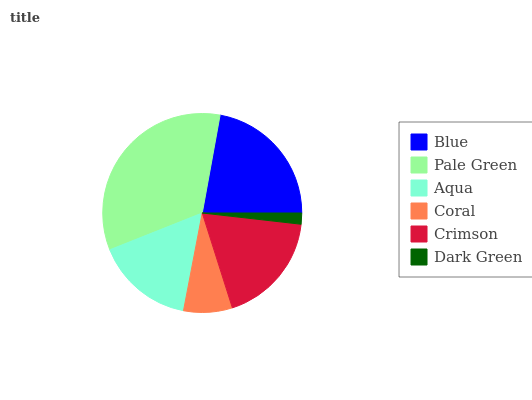Is Dark Green the minimum?
Answer yes or no. Yes. Is Pale Green the maximum?
Answer yes or no. Yes. Is Aqua the minimum?
Answer yes or no. No. Is Aqua the maximum?
Answer yes or no. No. Is Pale Green greater than Aqua?
Answer yes or no. Yes. Is Aqua less than Pale Green?
Answer yes or no. Yes. Is Aqua greater than Pale Green?
Answer yes or no. No. Is Pale Green less than Aqua?
Answer yes or no. No. Is Crimson the high median?
Answer yes or no. Yes. Is Aqua the low median?
Answer yes or no. Yes. Is Pale Green the high median?
Answer yes or no. No. Is Crimson the low median?
Answer yes or no. No. 